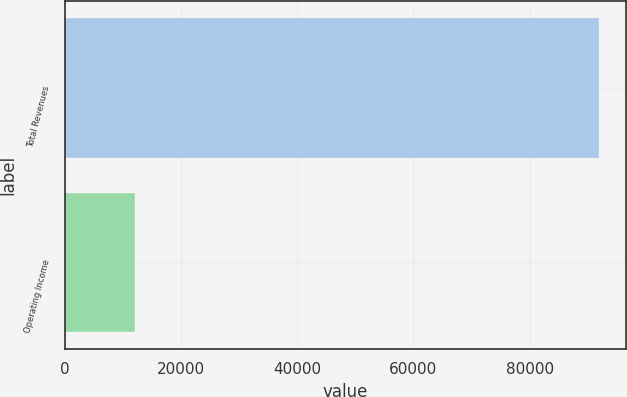<chart> <loc_0><loc_0><loc_500><loc_500><bar_chart><fcel>Total Revenues<fcel>Operating Income<nl><fcel>91997<fcel>12159<nl></chart> 